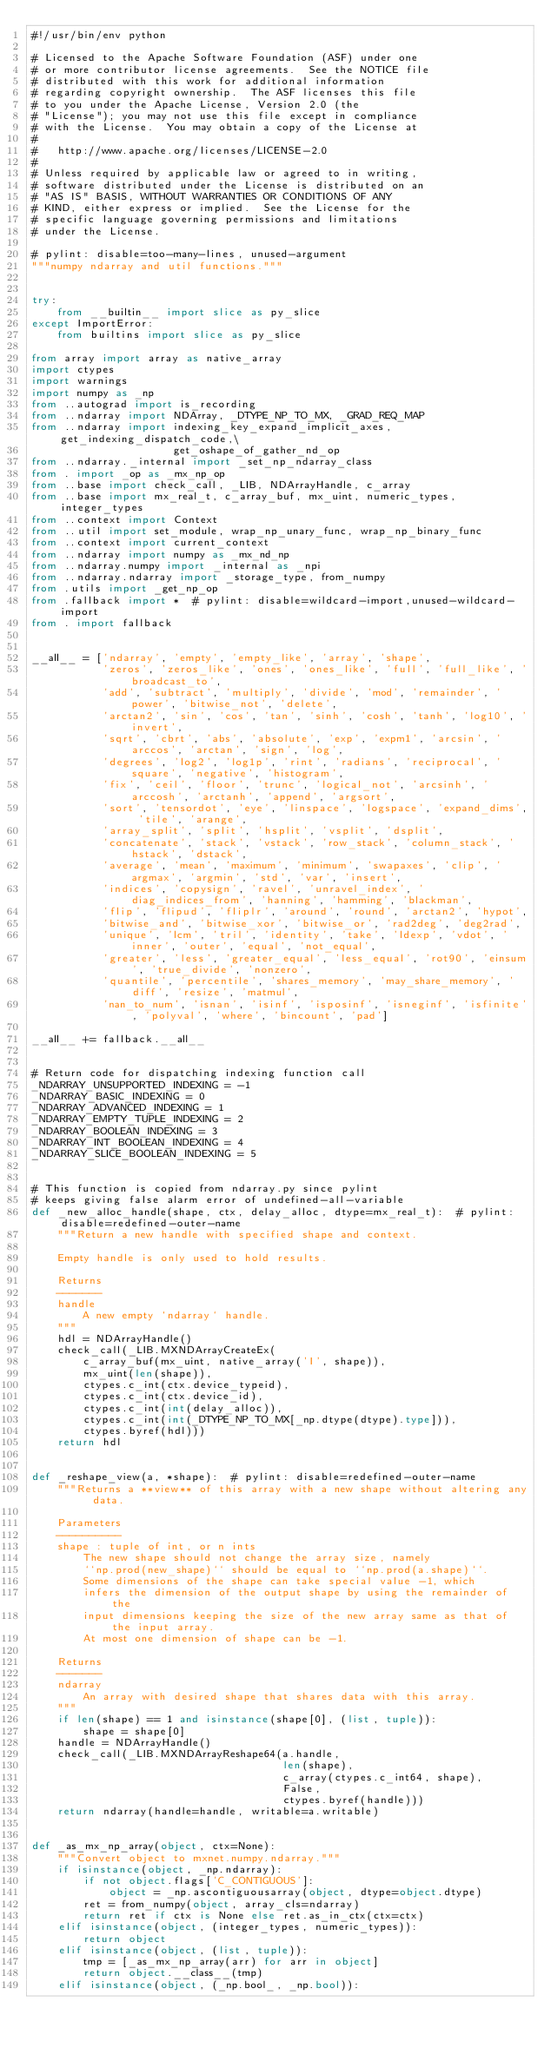Convert code to text. <code><loc_0><loc_0><loc_500><loc_500><_Python_>#!/usr/bin/env python

# Licensed to the Apache Software Foundation (ASF) under one
# or more contributor license agreements.  See the NOTICE file
# distributed with this work for additional information
# regarding copyright ownership.  The ASF licenses this file
# to you under the Apache License, Version 2.0 (the
# "License"); you may not use this file except in compliance
# with the License.  You may obtain a copy of the License at
#
#   http://www.apache.org/licenses/LICENSE-2.0
#
# Unless required by applicable law or agreed to in writing,
# software distributed under the License is distributed on an
# "AS IS" BASIS, WITHOUT WARRANTIES OR CONDITIONS OF ANY
# KIND, either express or implied.  See the License for the
# specific language governing permissions and limitations
# under the License.

# pylint: disable=too-many-lines, unused-argument
"""numpy ndarray and util functions."""


try:
    from __builtin__ import slice as py_slice
except ImportError:
    from builtins import slice as py_slice

from array import array as native_array
import ctypes
import warnings
import numpy as _np
from ..autograd import is_recording
from ..ndarray import NDArray, _DTYPE_NP_TO_MX, _GRAD_REQ_MAP
from ..ndarray import indexing_key_expand_implicit_axes, get_indexing_dispatch_code,\
                      get_oshape_of_gather_nd_op
from ..ndarray._internal import _set_np_ndarray_class
from . import _op as _mx_np_op
from ..base import check_call, _LIB, NDArrayHandle, c_array
from ..base import mx_real_t, c_array_buf, mx_uint, numeric_types, integer_types
from ..context import Context
from ..util import set_module, wrap_np_unary_func, wrap_np_binary_func
from ..context import current_context
from ..ndarray import numpy as _mx_nd_np
from ..ndarray.numpy import _internal as _npi
from ..ndarray.ndarray import _storage_type, from_numpy
from .utils import _get_np_op
from .fallback import *  # pylint: disable=wildcard-import,unused-wildcard-import
from . import fallback


__all__ = ['ndarray', 'empty', 'empty_like', 'array', 'shape',
           'zeros', 'zeros_like', 'ones', 'ones_like', 'full', 'full_like', 'broadcast_to',
           'add', 'subtract', 'multiply', 'divide', 'mod', 'remainder', 'power', 'bitwise_not', 'delete',
           'arctan2', 'sin', 'cos', 'tan', 'sinh', 'cosh', 'tanh', 'log10', 'invert',
           'sqrt', 'cbrt', 'abs', 'absolute', 'exp', 'expm1', 'arcsin', 'arccos', 'arctan', 'sign', 'log',
           'degrees', 'log2', 'log1p', 'rint', 'radians', 'reciprocal', 'square', 'negative', 'histogram',
           'fix', 'ceil', 'floor', 'trunc', 'logical_not', 'arcsinh', 'arccosh', 'arctanh', 'append', 'argsort',
           'sort', 'tensordot', 'eye', 'linspace', 'logspace', 'expand_dims', 'tile', 'arange',
           'array_split', 'split', 'hsplit', 'vsplit', 'dsplit',
           'concatenate', 'stack', 'vstack', 'row_stack', 'column_stack', 'hstack', 'dstack',
           'average', 'mean', 'maximum', 'minimum', 'swapaxes', 'clip', 'argmax', 'argmin', 'std', 'var', 'insert',
           'indices', 'copysign', 'ravel', 'unravel_index', 'diag_indices_from', 'hanning', 'hamming', 'blackman',
           'flip', 'flipud', 'fliplr', 'around', 'round', 'arctan2', 'hypot',
           'bitwise_and', 'bitwise_xor', 'bitwise_or', 'rad2deg', 'deg2rad',
           'unique', 'lcm', 'tril', 'identity', 'take', 'ldexp', 'vdot', 'inner', 'outer', 'equal', 'not_equal',
           'greater', 'less', 'greater_equal', 'less_equal', 'rot90', 'einsum', 'true_divide', 'nonzero',
           'quantile', 'percentile', 'shares_memory', 'may_share_memory', 'diff', 'resize', 'matmul',
           'nan_to_num', 'isnan', 'isinf', 'isposinf', 'isneginf', 'isfinite', 'polyval', 'where', 'bincount', 'pad']

__all__ += fallback.__all__


# Return code for dispatching indexing function call
_NDARRAY_UNSUPPORTED_INDEXING = -1
_NDARRAY_BASIC_INDEXING = 0
_NDARRAY_ADVANCED_INDEXING = 1
_NDARRAY_EMPTY_TUPLE_INDEXING = 2
_NDARRAY_BOOLEAN_INDEXING = 3
_NDARRAY_INT_BOOLEAN_INDEXING = 4
_NDARRAY_SLICE_BOOLEAN_INDEXING = 5


# This function is copied from ndarray.py since pylint
# keeps giving false alarm error of undefined-all-variable
def _new_alloc_handle(shape, ctx, delay_alloc, dtype=mx_real_t):  # pylint: disable=redefined-outer-name
    """Return a new handle with specified shape and context.

    Empty handle is only used to hold results.

    Returns
    -------
    handle
        A new empty `ndarray` handle.
    """
    hdl = NDArrayHandle()
    check_call(_LIB.MXNDArrayCreateEx(
        c_array_buf(mx_uint, native_array('I', shape)),
        mx_uint(len(shape)),
        ctypes.c_int(ctx.device_typeid),
        ctypes.c_int(ctx.device_id),
        ctypes.c_int(int(delay_alloc)),
        ctypes.c_int(int(_DTYPE_NP_TO_MX[_np.dtype(dtype).type])),
        ctypes.byref(hdl)))
    return hdl


def _reshape_view(a, *shape):  # pylint: disable=redefined-outer-name
    """Returns a **view** of this array with a new shape without altering any data.

    Parameters
    ----------
    shape : tuple of int, or n ints
        The new shape should not change the array size, namely
        ``np.prod(new_shape)`` should be equal to ``np.prod(a.shape)``.
        Some dimensions of the shape can take special value -1, which
        infers the dimension of the output shape by using the remainder of the
        input dimensions keeping the size of the new array same as that of the input array.
        At most one dimension of shape can be -1.

    Returns
    -------
    ndarray
        An array with desired shape that shares data with this array.
    """
    if len(shape) == 1 and isinstance(shape[0], (list, tuple)):
        shape = shape[0]
    handle = NDArrayHandle()
    check_call(_LIB.MXNDArrayReshape64(a.handle,
                                       len(shape),
                                       c_array(ctypes.c_int64, shape),
                                       False,
                                       ctypes.byref(handle)))
    return ndarray(handle=handle, writable=a.writable)


def _as_mx_np_array(object, ctx=None):
    """Convert object to mxnet.numpy.ndarray."""
    if isinstance(object, _np.ndarray):
        if not object.flags['C_CONTIGUOUS']:
            object = _np.ascontiguousarray(object, dtype=object.dtype)
        ret = from_numpy(object, array_cls=ndarray)
        return ret if ctx is None else ret.as_in_ctx(ctx=ctx)
    elif isinstance(object, (integer_types, numeric_types)):
        return object
    elif isinstance(object, (list, tuple)):
        tmp = [_as_mx_np_array(arr) for arr in object]
        return object.__class__(tmp)
    elif isinstance(object, (_np.bool_, _np.bool)):</code> 